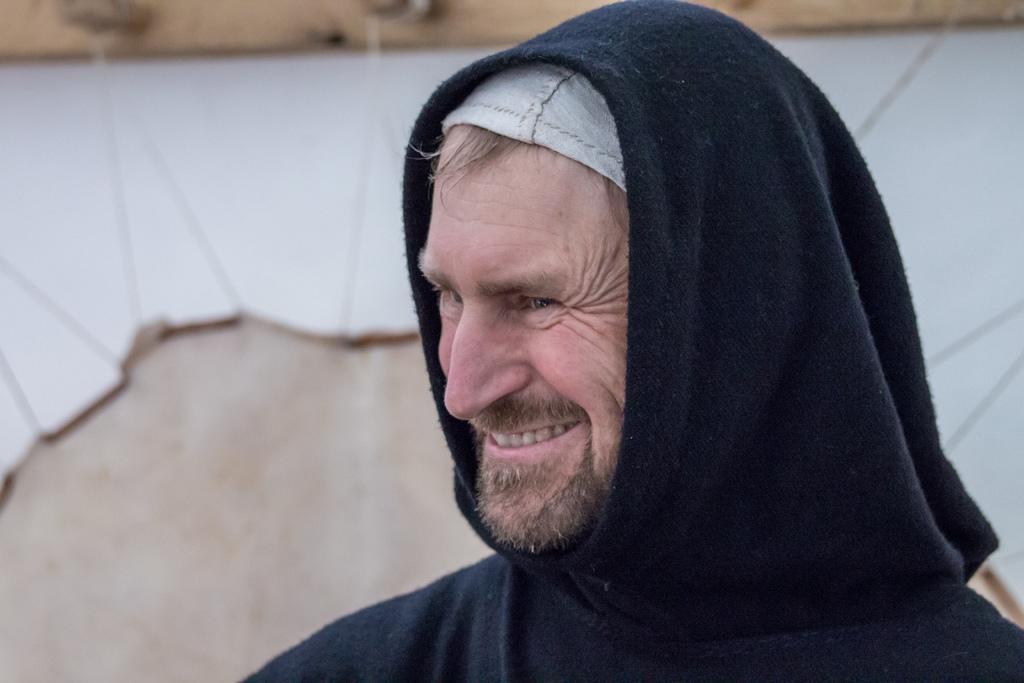Please provide a concise description of this image. In this image I can see the person is smiling and wearing black and white color dress. Background is in cream and white color. 